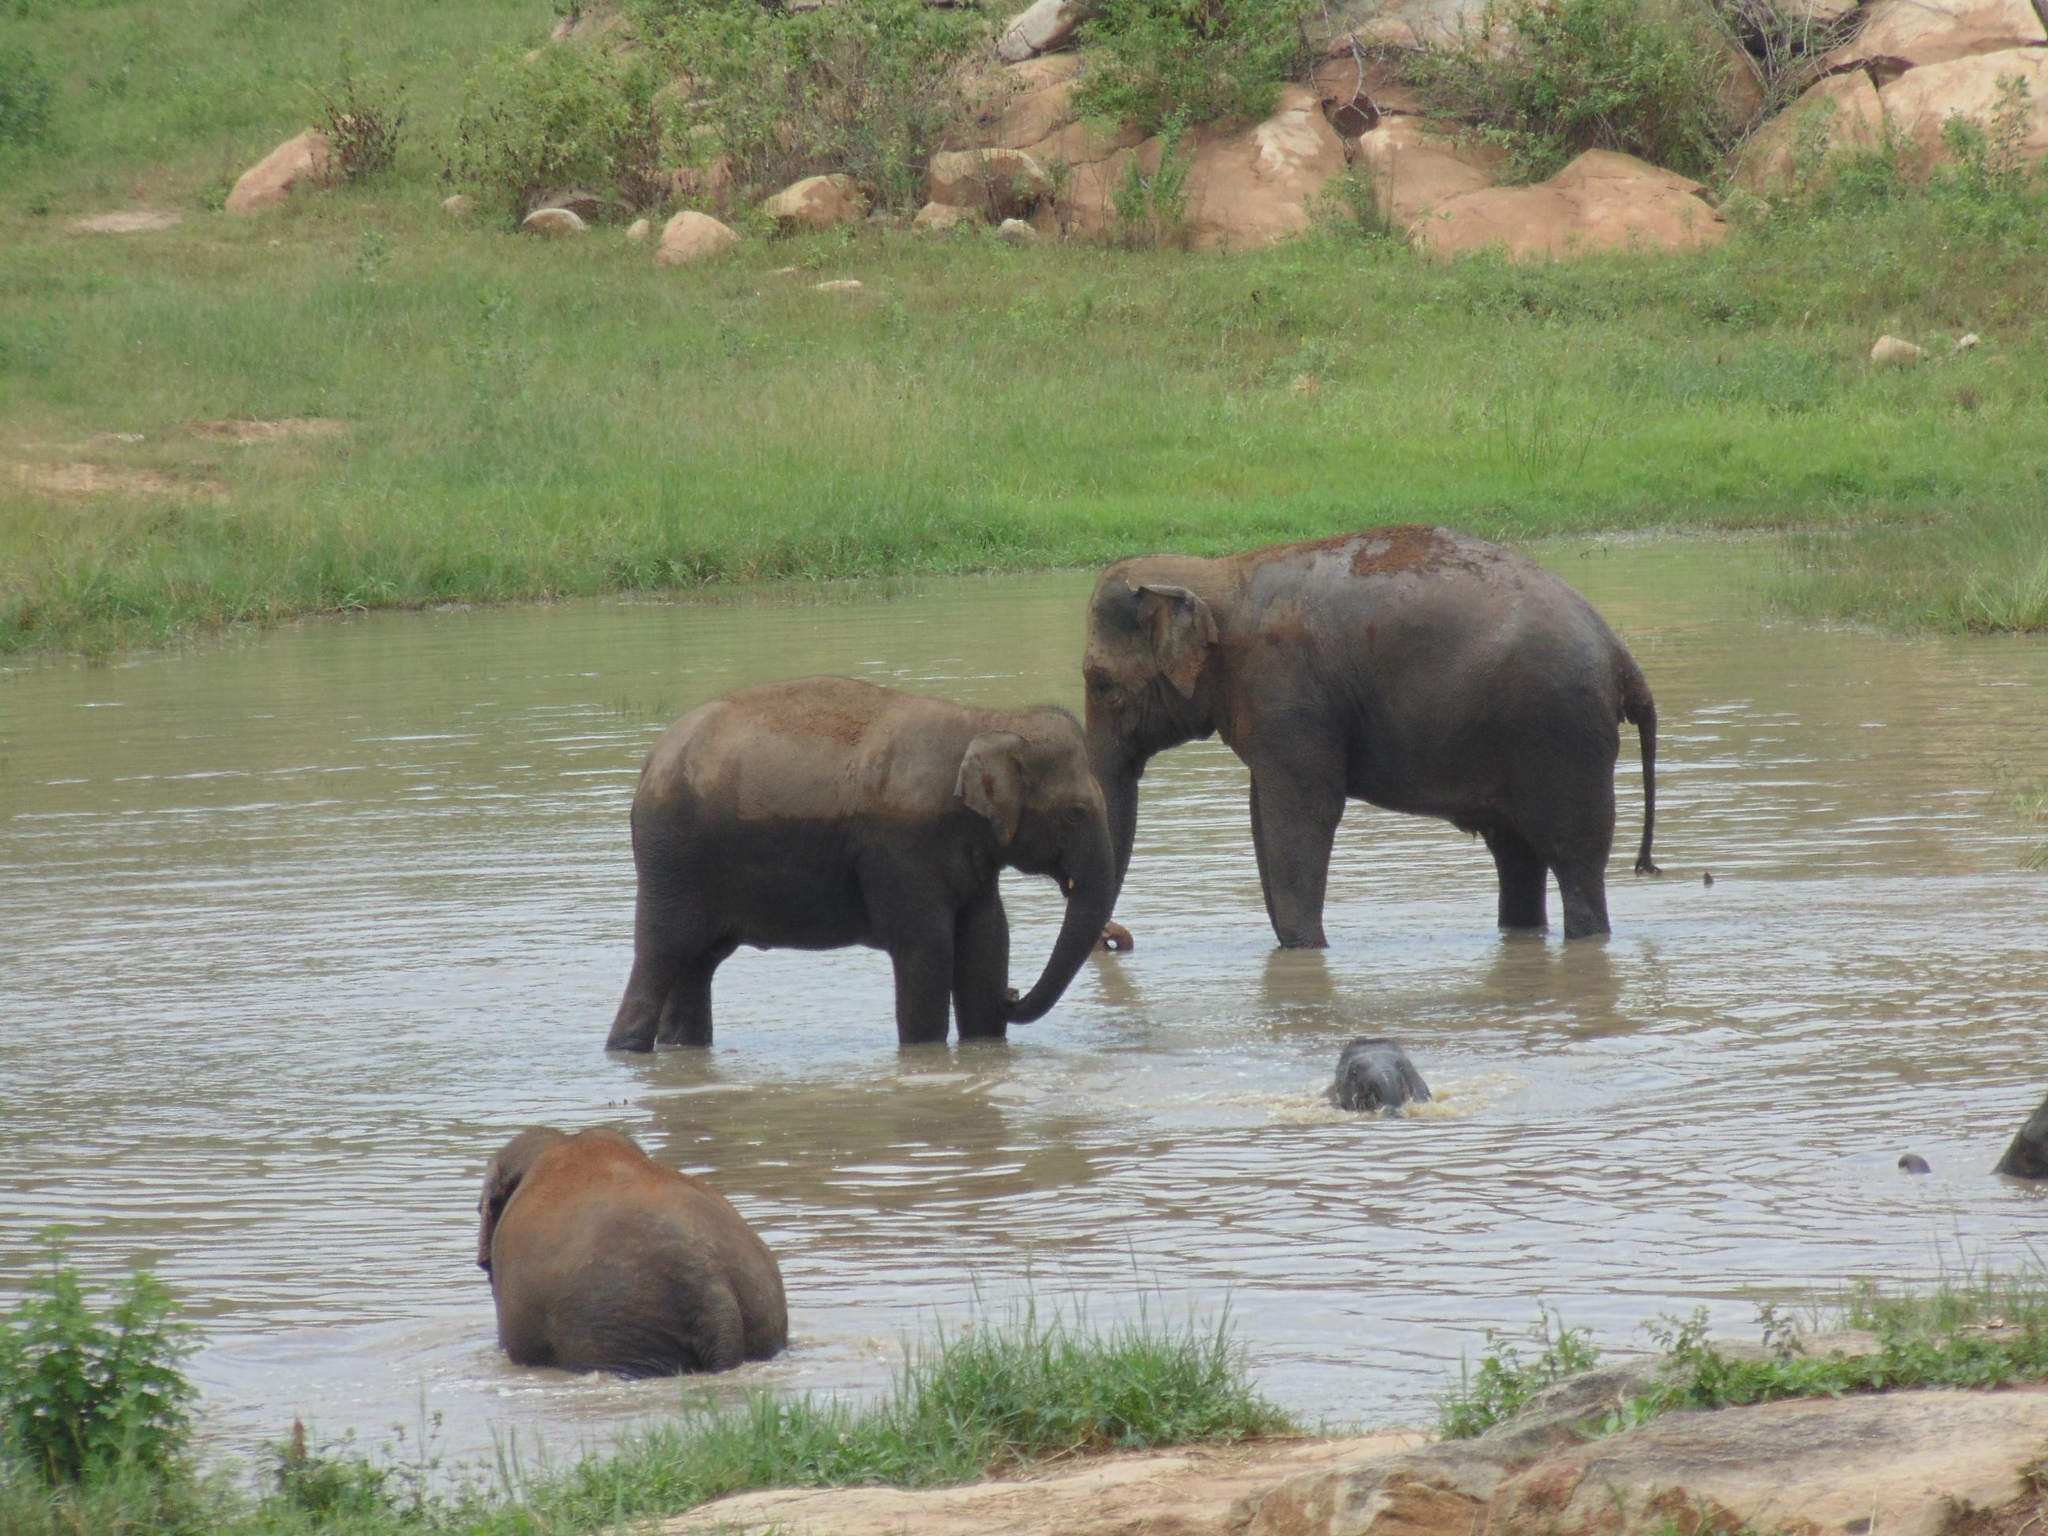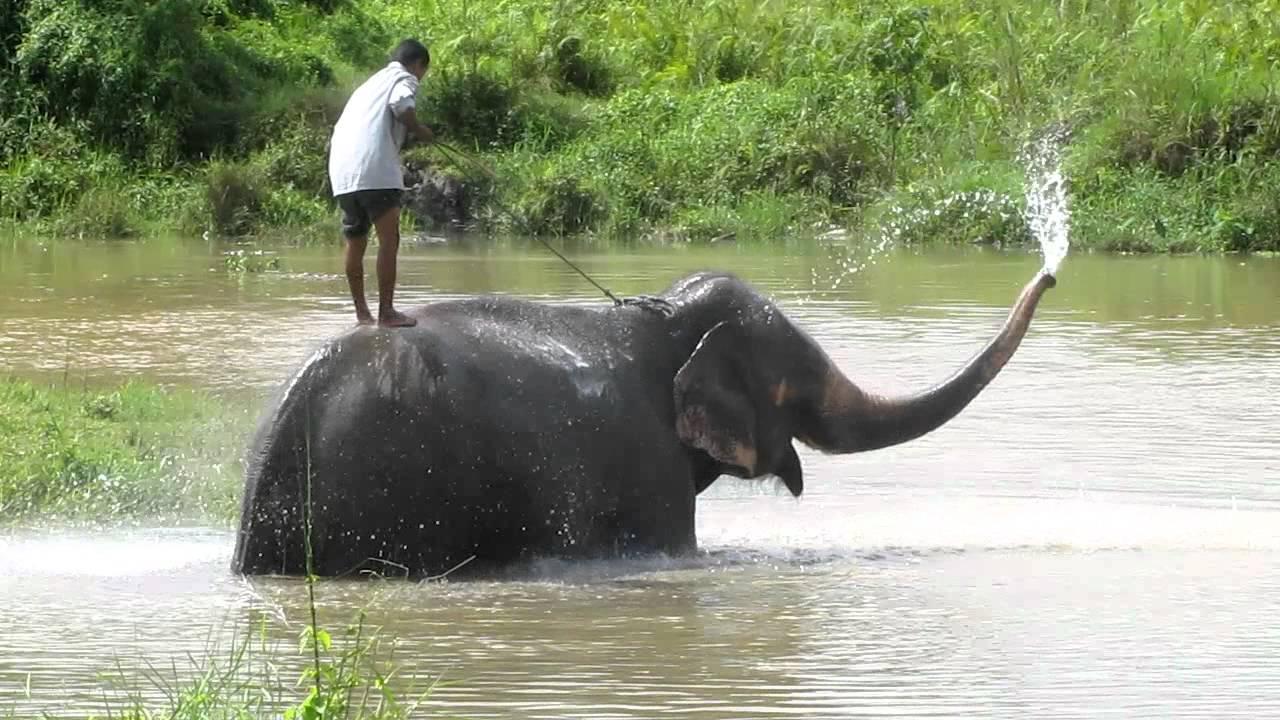The first image is the image on the left, the second image is the image on the right. Evaluate the accuracy of this statement regarding the images: "There are at least four elephants in the water.". Is it true? Answer yes or no. Yes. The first image is the image on the left, the second image is the image on the right. Analyze the images presented: Is the assertion "One of the images contains exactly four elephants." valid? Answer yes or no. No. 